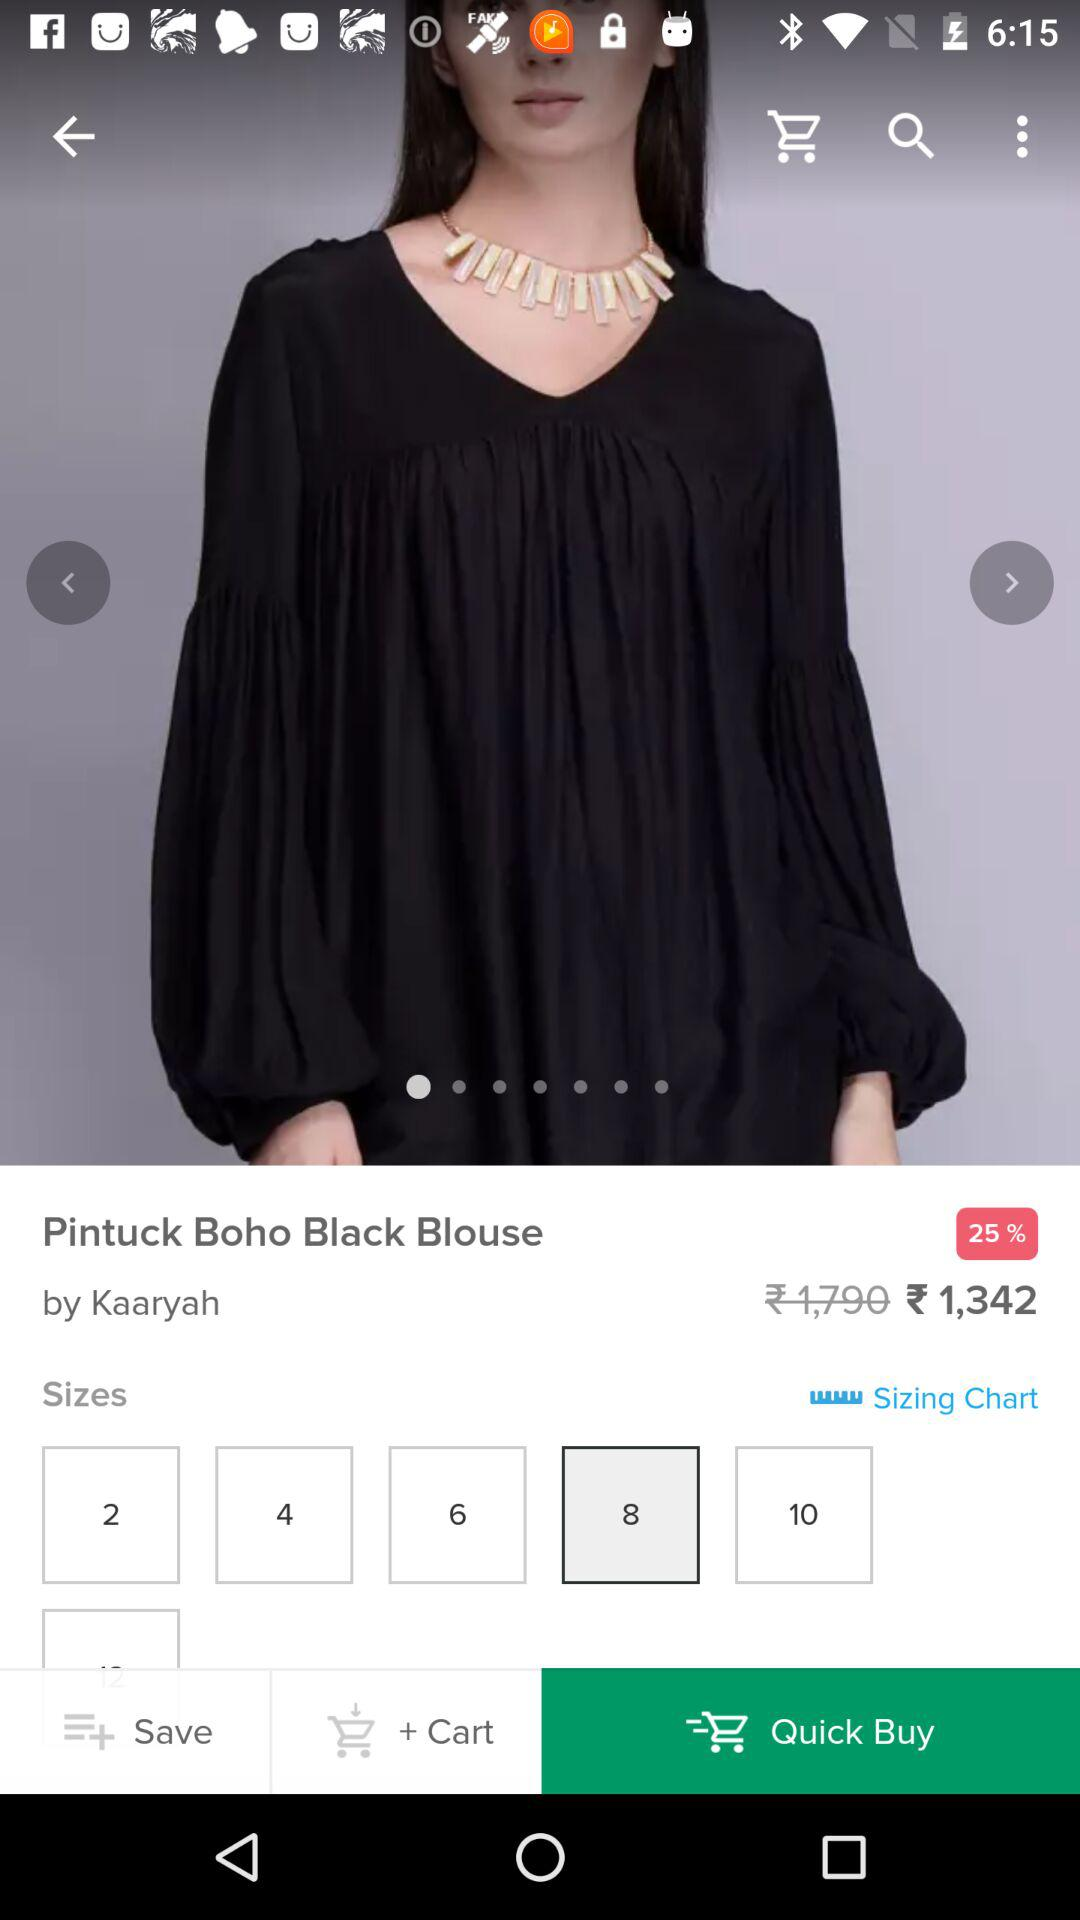What is the brand of the blouse? The brand name is Kaaryah. 